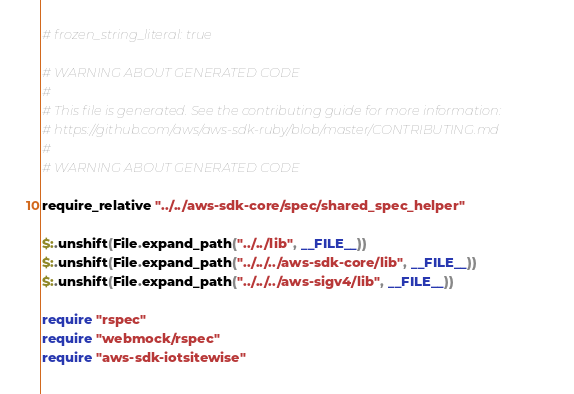<code> <loc_0><loc_0><loc_500><loc_500><_Crystal_># frozen_string_literal: true

# WARNING ABOUT GENERATED CODE
#
# This file is generated. See the contributing guide for more information:
# https://github.com/aws/aws-sdk-ruby/blob/master/CONTRIBUTING.md
#
# WARNING ABOUT GENERATED CODE

require_relative "../../aws-sdk-core/spec/shared_spec_helper"

$:.unshift(File.expand_path("../../lib", __FILE__))
$:.unshift(File.expand_path("../../../aws-sdk-core/lib", __FILE__))
$:.unshift(File.expand_path("../../../aws-sigv4/lib", __FILE__))

require "rspec"
require "webmock/rspec"
require "aws-sdk-iotsitewise"
</code> 